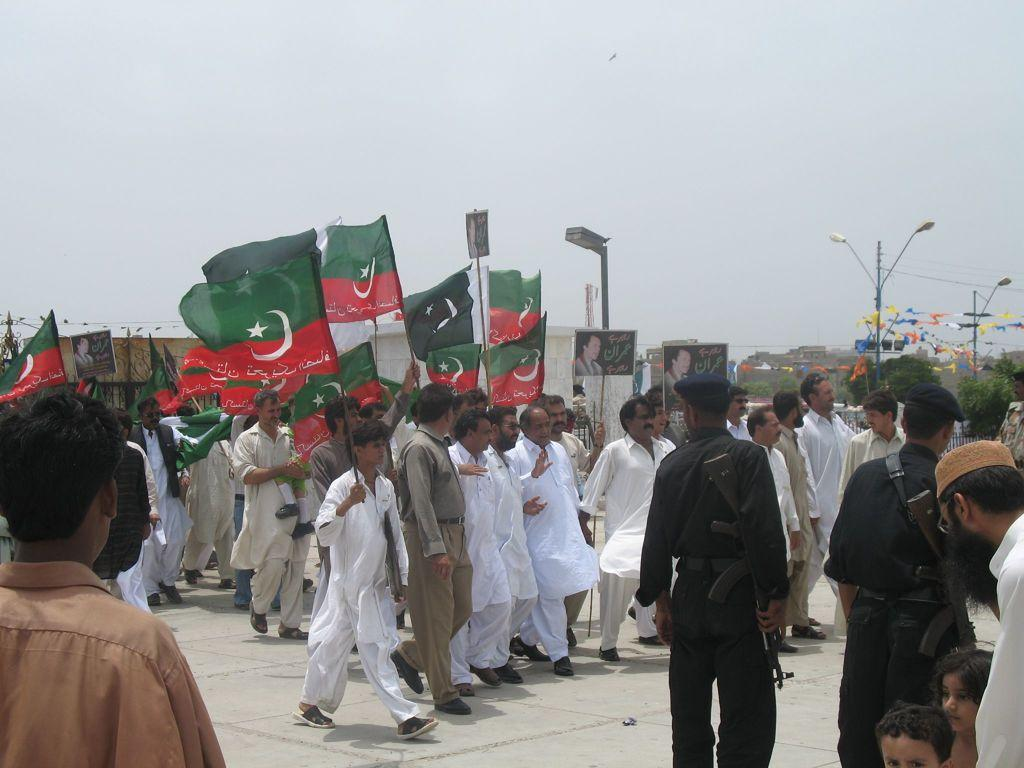What are the people in the image holding? The people in the image are holding flags. What can be seen in the background of the image? There are streetlights and the sky visible in the background of the image. What type of liquid is being poured from the crown in the image? There is no crown or liquid present in the image. 